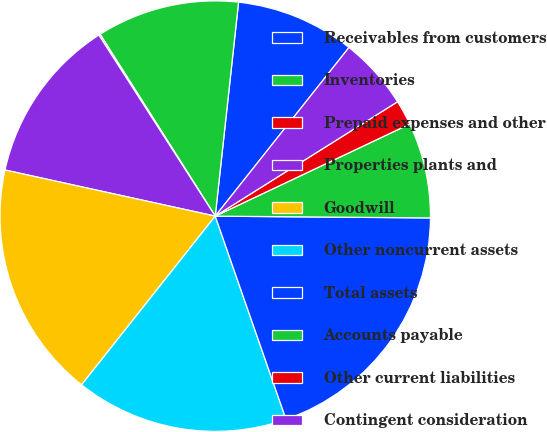<chart> <loc_0><loc_0><loc_500><loc_500><pie_chart><fcel>Receivables from customers<fcel>Inventories<fcel>Prepaid expenses and other<fcel>Properties plants and<fcel>Goodwill<fcel>Other noncurrent assets<fcel>Total assets<fcel>Accounts payable<fcel>Other current liabilities<fcel>Contingent consideration<nl><fcel>8.94%<fcel>10.71%<fcel>0.11%<fcel>12.47%<fcel>17.77%<fcel>16.0%<fcel>19.53%<fcel>7.17%<fcel>1.88%<fcel>5.41%<nl></chart> 